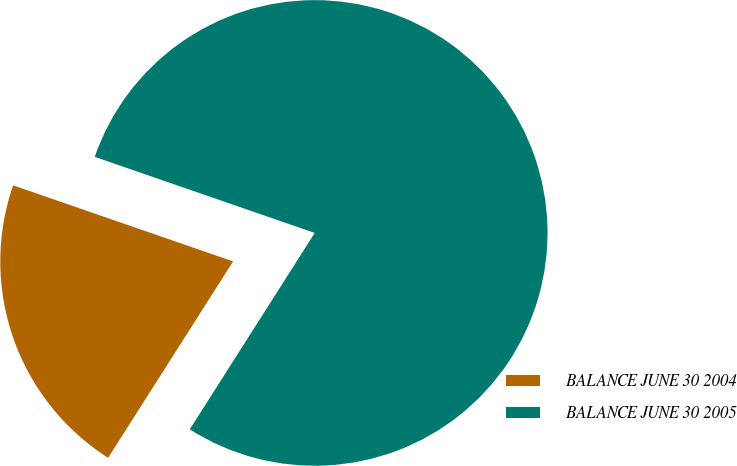<chart> <loc_0><loc_0><loc_500><loc_500><pie_chart><fcel>BALANCE JUNE 30 2004<fcel>BALANCE JUNE 30 2005<nl><fcel>21.28%<fcel>78.72%<nl></chart> 